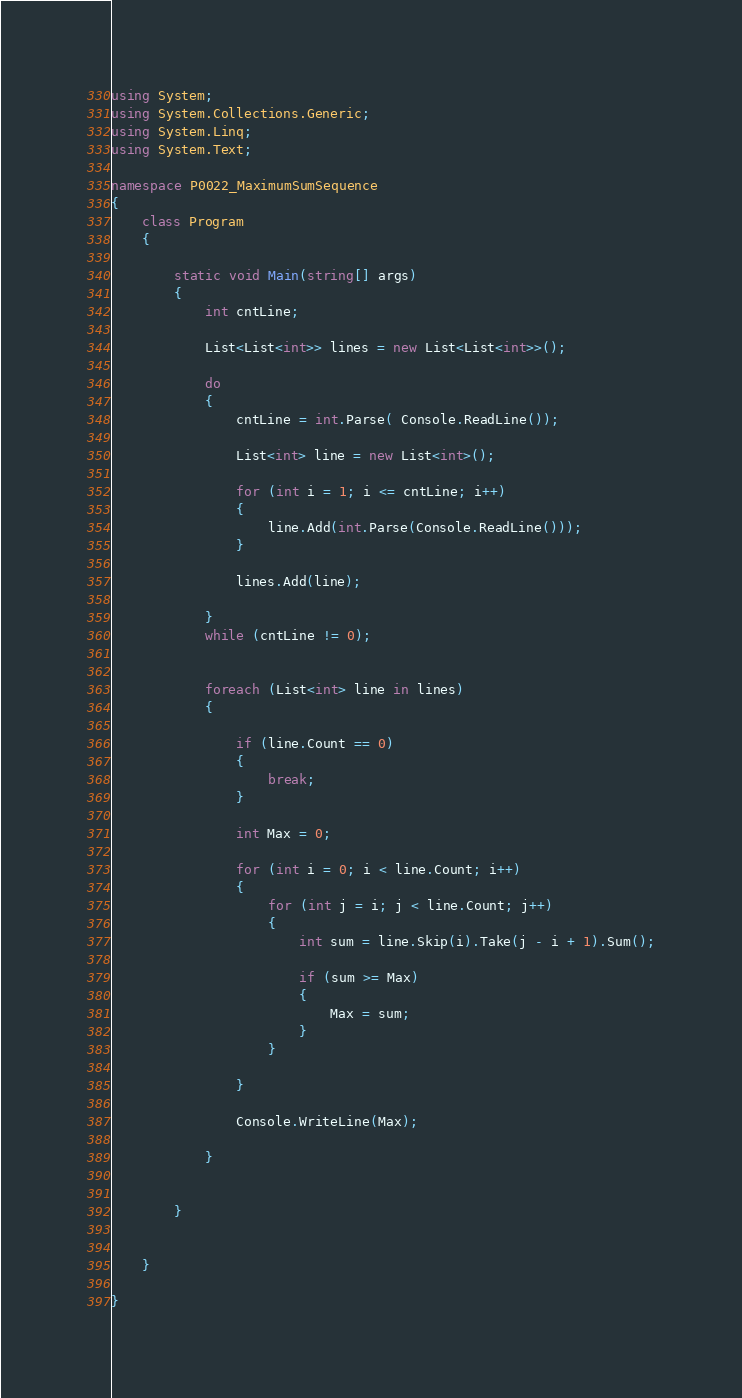Convert code to text. <code><loc_0><loc_0><loc_500><loc_500><_C#_>using System;
using System.Collections.Generic;
using System.Linq;
using System.Text;

namespace P0022_MaximumSumSequence
{
    class Program
    {

        static void Main(string[] args)
        {
            int cntLine;

            List<List<int>> lines = new List<List<int>>();

            do
            {
                cntLine = int.Parse( Console.ReadLine());
                
                List<int> line = new List<int>();

                for (int i = 1; i <= cntLine; i++) 
                {
                    line.Add(int.Parse(Console.ReadLine()));
                }

                lines.Add(line);

            }
            while (cntLine != 0);
            

            foreach (List<int> line in lines)
            {

                if (line.Count == 0) 
                {
                    break;
                }

                int Max = 0;

                for (int i = 0; i < line.Count; i++) 
                {
                    for (int j = i; j < line.Count; j++)
                    {
                        int sum = line.Skip(i).Take(j - i + 1).Sum();

                        if (sum >= Max) 
                        {
                            Max = sum;
                        }
                    }

                }

                Console.WriteLine(Max);

            }


        }


    }

}</code> 